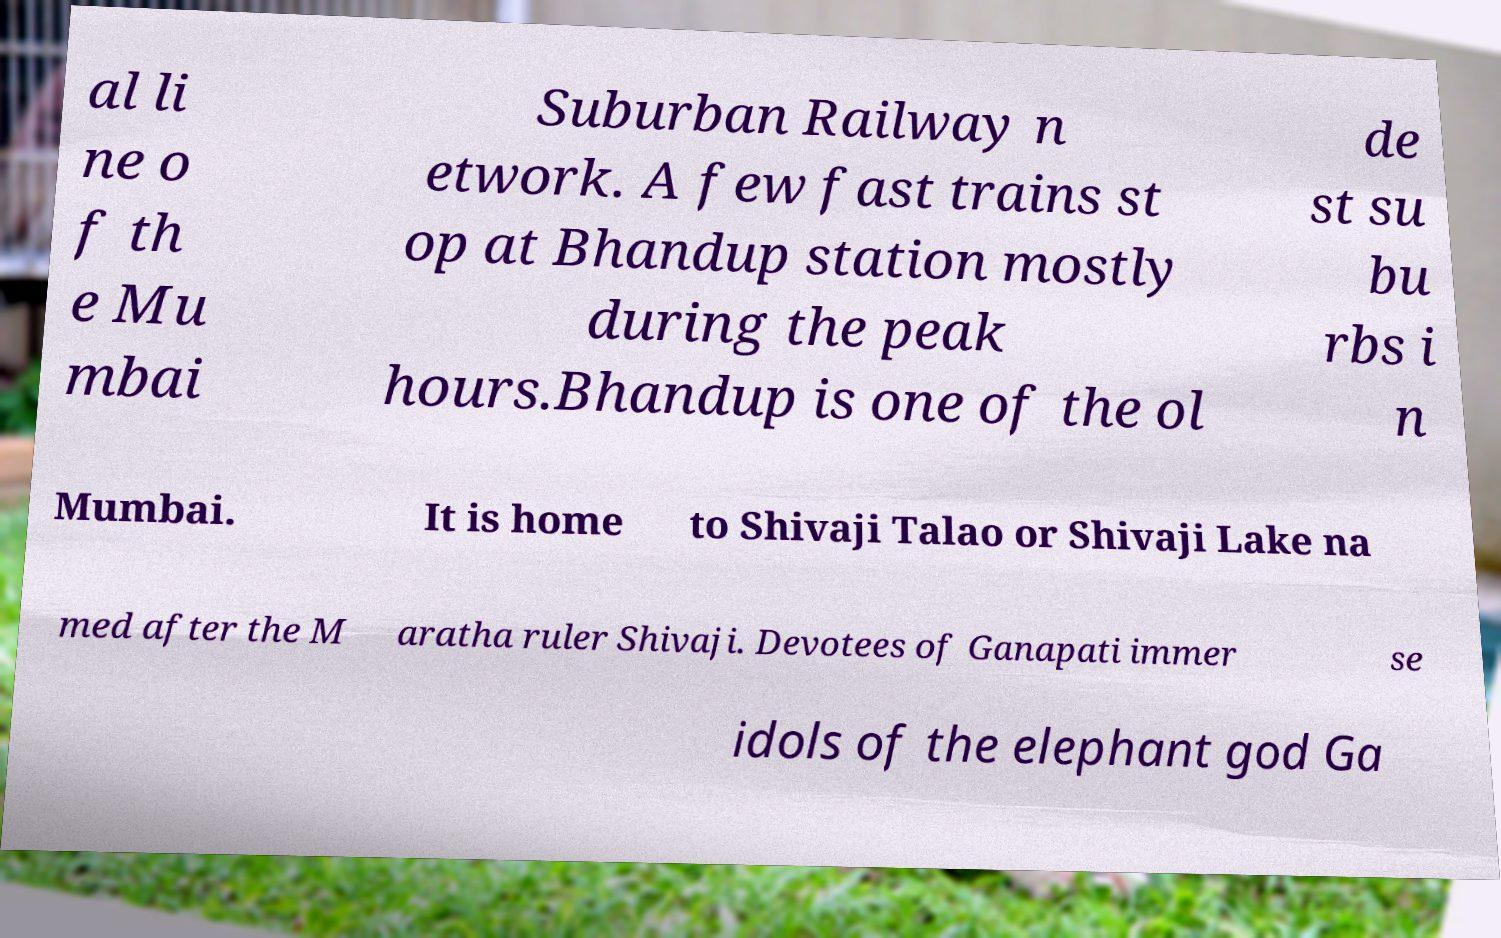I need the written content from this picture converted into text. Can you do that? al li ne o f th e Mu mbai Suburban Railway n etwork. A few fast trains st op at Bhandup station mostly during the peak hours.Bhandup is one of the ol de st su bu rbs i n Mumbai. It is home to Shivaji Talao or Shivaji Lake na med after the M aratha ruler Shivaji. Devotees of Ganapati immer se idols of the elephant god Ga 